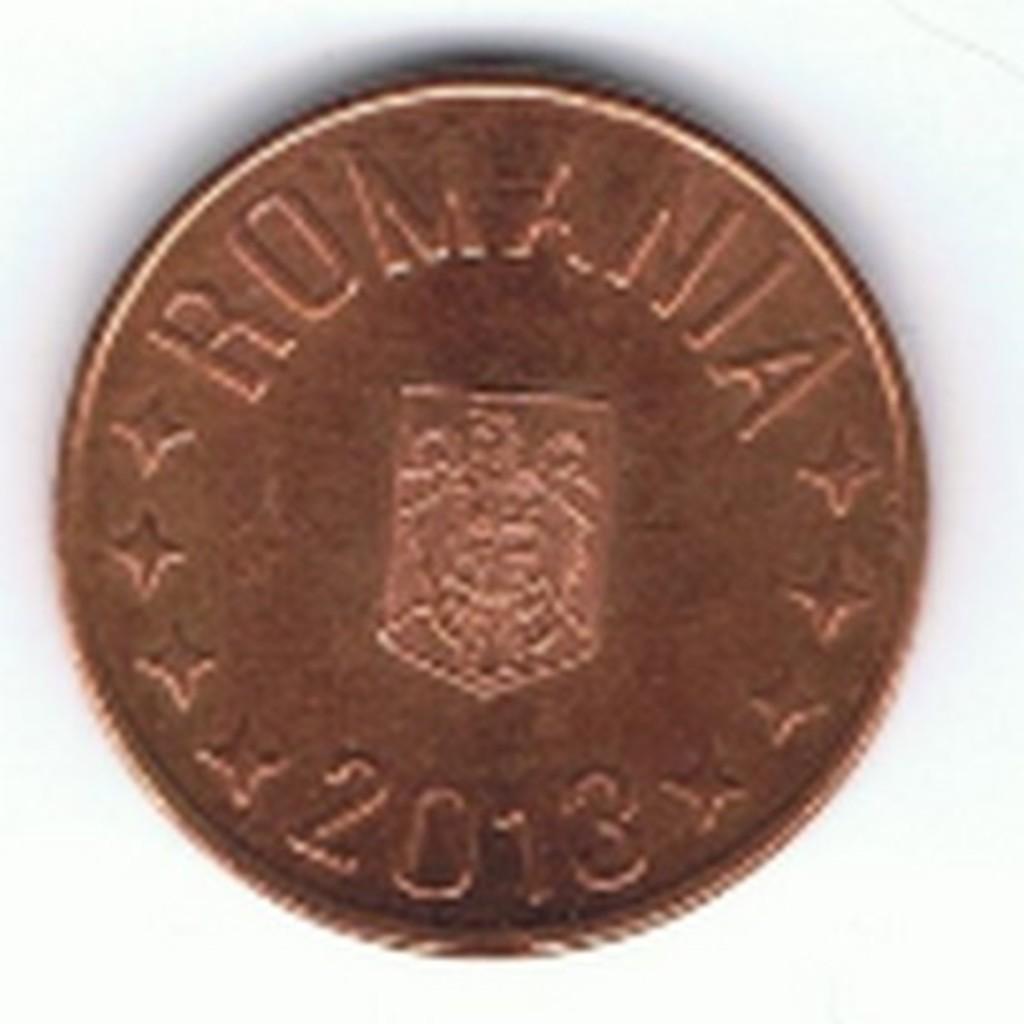What country is this coin from?
Give a very brief answer. Romania. What is the date on the coin?
Your answer should be very brief. 2013. 